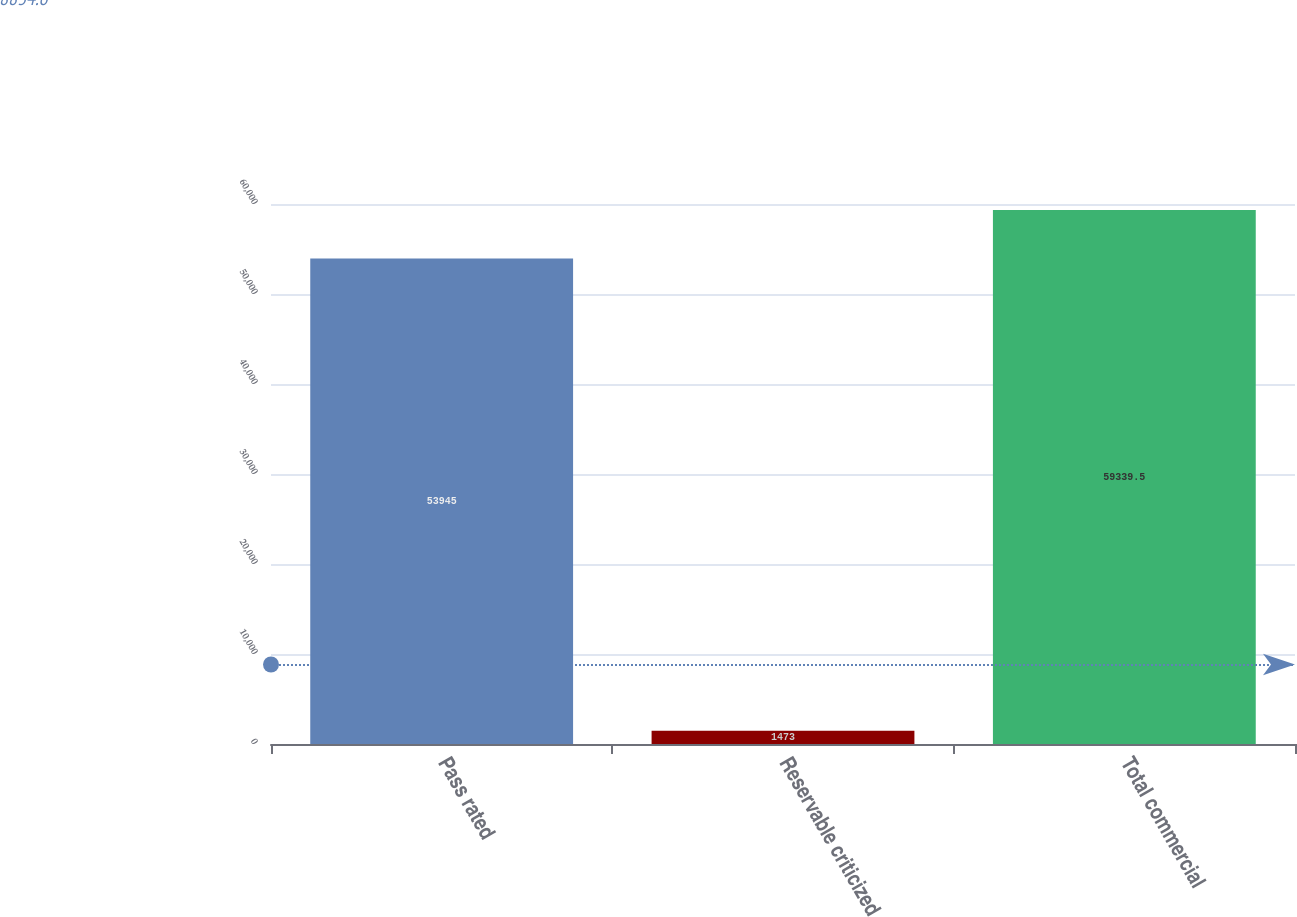<chart> <loc_0><loc_0><loc_500><loc_500><bar_chart><fcel>Pass rated<fcel>Reservable criticized<fcel>Total commercial<nl><fcel>53945<fcel>1473<fcel>59339.5<nl></chart> 